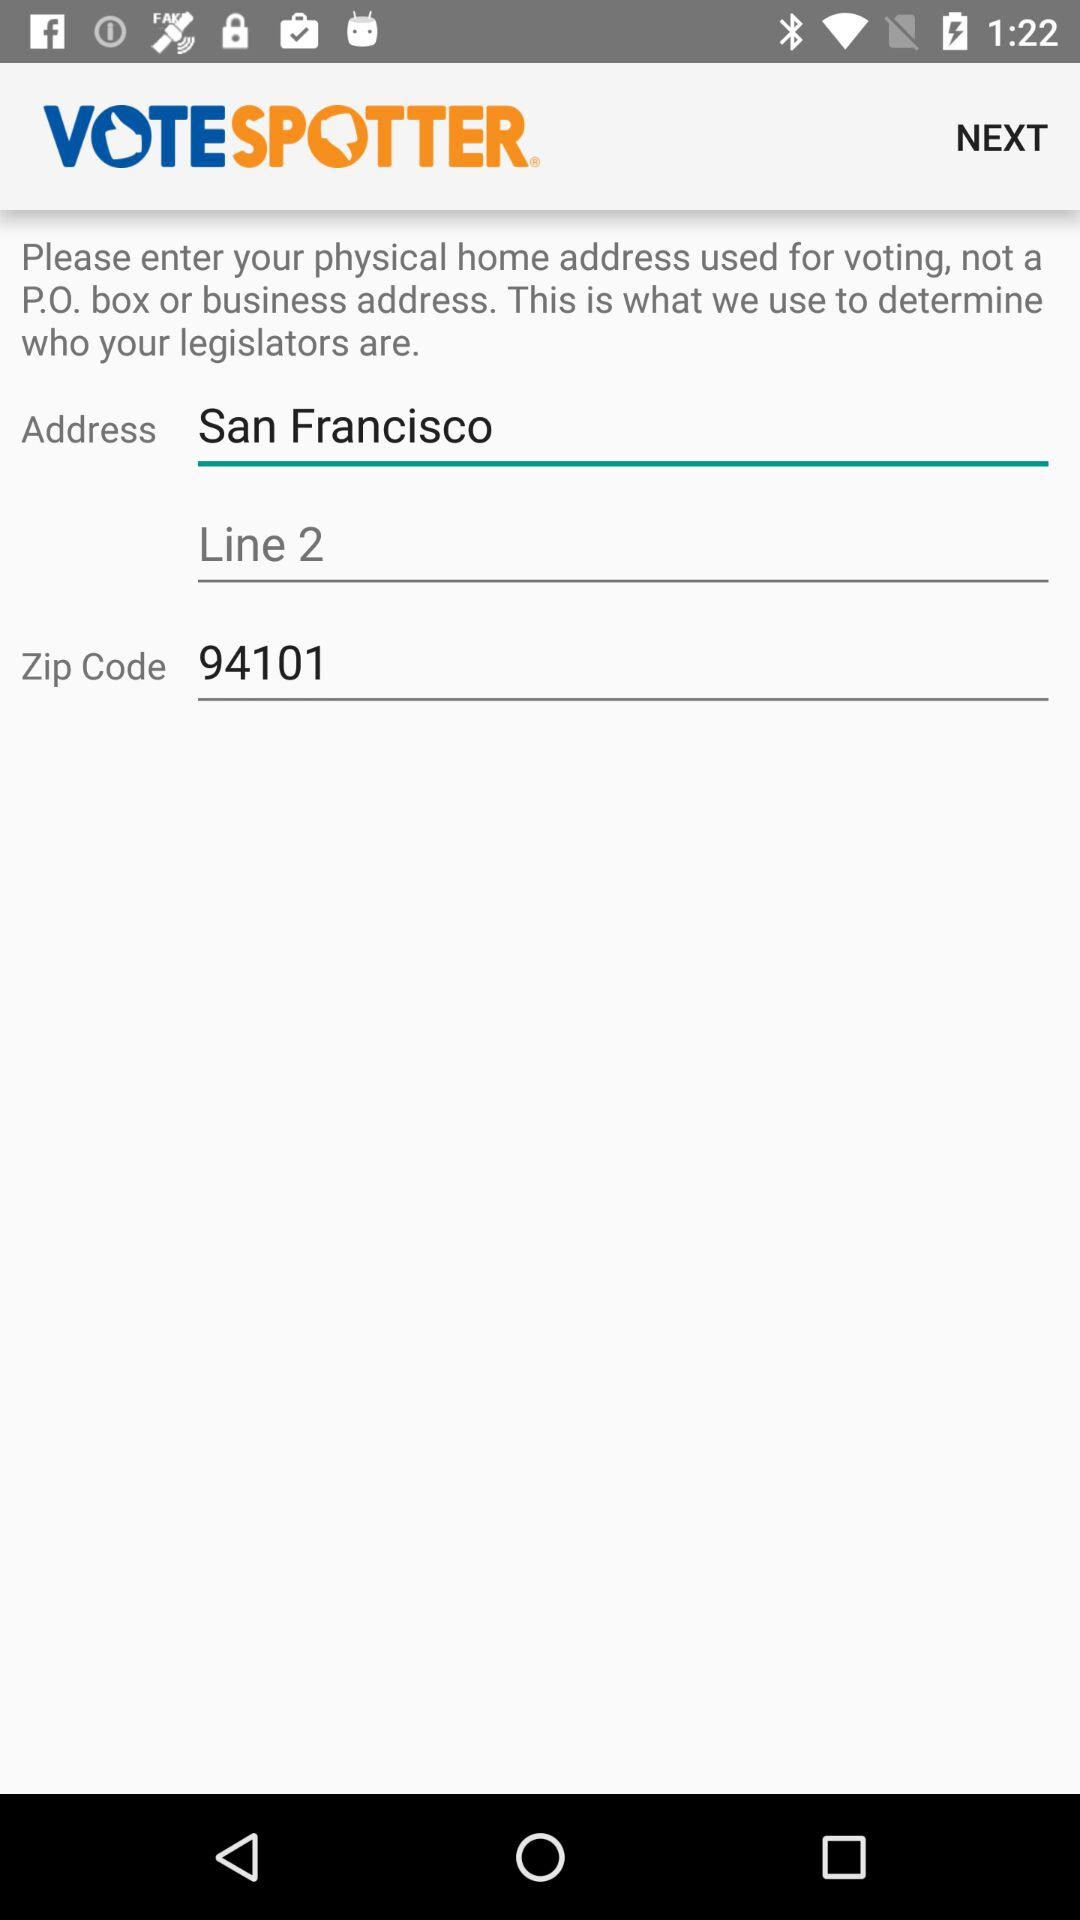What is the zip code? The zip code is 94101. 